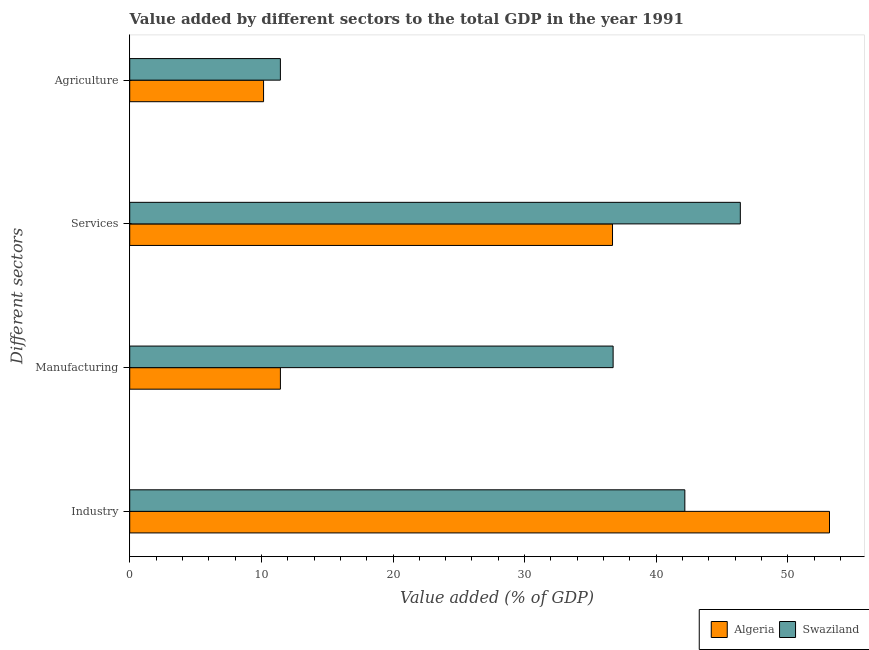How many different coloured bars are there?
Provide a short and direct response. 2. How many bars are there on the 2nd tick from the top?
Make the answer very short. 2. How many bars are there on the 4th tick from the bottom?
Ensure brevity in your answer.  2. What is the label of the 4th group of bars from the top?
Offer a very short reply. Industry. What is the value added by industrial sector in Algeria?
Offer a terse response. 53.16. Across all countries, what is the maximum value added by services sector?
Make the answer very short. 46.38. Across all countries, what is the minimum value added by manufacturing sector?
Keep it short and to the point. 11.45. In which country was the value added by services sector maximum?
Offer a terse response. Swaziland. In which country was the value added by industrial sector minimum?
Your answer should be compact. Swaziland. What is the total value added by services sector in the graph?
Offer a very short reply. 83.06. What is the difference between the value added by services sector in Swaziland and that in Algeria?
Give a very brief answer. 9.71. What is the difference between the value added by services sector in Algeria and the value added by agricultural sector in Swaziland?
Ensure brevity in your answer.  25.23. What is the average value added by agricultural sector per country?
Keep it short and to the point. 10.81. What is the difference between the value added by services sector and value added by industrial sector in Algeria?
Ensure brevity in your answer.  -16.48. What is the ratio of the value added by agricultural sector in Algeria to that in Swaziland?
Provide a short and direct response. 0.89. Is the value added by agricultural sector in Swaziland less than that in Algeria?
Your response must be concise. No. What is the difference between the highest and the second highest value added by industrial sector?
Provide a succinct answer. 10.99. What is the difference between the highest and the lowest value added by agricultural sector?
Make the answer very short. 1.28. What does the 1st bar from the top in Manufacturing represents?
Offer a very short reply. Swaziland. What does the 2nd bar from the bottom in Services represents?
Ensure brevity in your answer.  Swaziland. Is it the case that in every country, the sum of the value added by industrial sector and value added by manufacturing sector is greater than the value added by services sector?
Ensure brevity in your answer.  Yes. How many bars are there?
Give a very brief answer. 8. Are all the bars in the graph horizontal?
Offer a terse response. Yes. Are the values on the major ticks of X-axis written in scientific E-notation?
Provide a succinct answer. No. Does the graph contain grids?
Your answer should be compact. No. Where does the legend appear in the graph?
Offer a terse response. Bottom right. How many legend labels are there?
Offer a terse response. 2. How are the legend labels stacked?
Offer a very short reply. Horizontal. What is the title of the graph?
Your answer should be very brief. Value added by different sectors to the total GDP in the year 1991. Does "Vanuatu" appear as one of the legend labels in the graph?
Make the answer very short. No. What is the label or title of the X-axis?
Provide a short and direct response. Value added (% of GDP). What is the label or title of the Y-axis?
Your answer should be very brief. Different sectors. What is the Value added (% of GDP) in Algeria in Industry?
Provide a succinct answer. 53.16. What is the Value added (% of GDP) in Swaziland in Industry?
Keep it short and to the point. 42.17. What is the Value added (% of GDP) in Algeria in Manufacturing?
Your answer should be compact. 11.45. What is the Value added (% of GDP) in Swaziland in Manufacturing?
Make the answer very short. 36.72. What is the Value added (% of GDP) of Algeria in Services?
Your response must be concise. 36.67. What is the Value added (% of GDP) of Swaziland in Services?
Keep it short and to the point. 46.38. What is the Value added (% of GDP) in Algeria in Agriculture?
Give a very brief answer. 10.17. What is the Value added (% of GDP) of Swaziland in Agriculture?
Offer a very short reply. 11.45. Across all Different sectors, what is the maximum Value added (% of GDP) of Algeria?
Provide a succinct answer. 53.16. Across all Different sectors, what is the maximum Value added (% of GDP) in Swaziland?
Your answer should be very brief. 46.38. Across all Different sectors, what is the minimum Value added (% of GDP) in Algeria?
Keep it short and to the point. 10.17. Across all Different sectors, what is the minimum Value added (% of GDP) in Swaziland?
Keep it short and to the point. 11.45. What is the total Value added (% of GDP) in Algeria in the graph?
Your answer should be compact. 111.45. What is the total Value added (% of GDP) in Swaziland in the graph?
Offer a terse response. 136.72. What is the difference between the Value added (% of GDP) of Algeria in Industry and that in Manufacturing?
Ensure brevity in your answer.  41.71. What is the difference between the Value added (% of GDP) in Swaziland in Industry and that in Manufacturing?
Your answer should be compact. 5.45. What is the difference between the Value added (% of GDP) in Algeria in Industry and that in Services?
Offer a very short reply. 16.48. What is the difference between the Value added (% of GDP) of Swaziland in Industry and that in Services?
Provide a succinct answer. -4.21. What is the difference between the Value added (% of GDP) of Algeria in Industry and that in Agriculture?
Provide a short and direct response. 42.99. What is the difference between the Value added (% of GDP) of Swaziland in Industry and that in Agriculture?
Keep it short and to the point. 30.72. What is the difference between the Value added (% of GDP) in Algeria in Manufacturing and that in Services?
Provide a short and direct response. -25.23. What is the difference between the Value added (% of GDP) of Swaziland in Manufacturing and that in Services?
Provide a short and direct response. -9.66. What is the difference between the Value added (% of GDP) in Algeria in Manufacturing and that in Agriculture?
Keep it short and to the point. 1.28. What is the difference between the Value added (% of GDP) in Swaziland in Manufacturing and that in Agriculture?
Ensure brevity in your answer.  25.28. What is the difference between the Value added (% of GDP) of Algeria in Services and that in Agriculture?
Keep it short and to the point. 26.51. What is the difference between the Value added (% of GDP) of Swaziland in Services and that in Agriculture?
Your answer should be very brief. 34.94. What is the difference between the Value added (% of GDP) in Algeria in Industry and the Value added (% of GDP) in Swaziland in Manufacturing?
Give a very brief answer. 16.44. What is the difference between the Value added (% of GDP) in Algeria in Industry and the Value added (% of GDP) in Swaziland in Services?
Your answer should be very brief. 6.77. What is the difference between the Value added (% of GDP) of Algeria in Industry and the Value added (% of GDP) of Swaziland in Agriculture?
Offer a terse response. 41.71. What is the difference between the Value added (% of GDP) in Algeria in Manufacturing and the Value added (% of GDP) in Swaziland in Services?
Give a very brief answer. -34.94. What is the difference between the Value added (% of GDP) of Algeria in Services and the Value added (% of GDP) of Swaziland in Agriculture?
Ensure brevity in your answer.  25.23. What is the average Value added (% of GDP) in Algeria per Different sectors?
Provide a short and direct response. 27.86. What is the average Value added (% of GDP) in Swaziland per Different sectors?
Give a very brief answer. 34.18. What is the difference between the Value added (% of GDP) in Algeria and Value added (% of GDP) in Swaziland in Industry?
Provide a short and direct response. 10.99. What is the difference between the Value added (% of GDP) in Algeria and Value added (% of GDP) in Swaziland in Manufacturing?
Your answer should be compact. -25.27. What is the difference between the Value added (% of GDP) of Algeria and Value added (% of GDP) of Swaziland in Services?
Provide a short and direct response. -9.71. What is the difference between the Value added (% of GDP) of Algeria and Value added (% of GDP) of Swaziland in Agriculture?
Offer a very short reply. -1.28. What is the ratio of the Value added (% of GDP) in Algeria in Industry to that in Manufacturing?
Your response must be concise. 4.64. What is the ratio of the Value added (% of GDP) in Swaziland in Industry to that in Manufacturing?
Provide a succinct answer. 1.15. What is the ratio of the Value added (% of GDP) in Algeria in Industry to that in Services?
Give a very brief answer. 1.45. What is the ratio of the Value added (% of GDP) of Algeria in Industry to that in Agriculture?
Give a very brief answer. 5.23. What is the ratio of the Value added (% of GDP) of Swaziland in Industry to that in Agriculture?
Your answer should be very brief. 3.68. What is the ratio of the Value added (% of GDP) in Algeria in Manufacturing to that in Services?
Keep it short and to the point. 0.31. What is the ratio of the Value added (% of GDP) of Swaziland in Manufacturing to that in Services?
Offer a terse response. 0.79. What is the ratio of the Value added (% of GDP) of Algeria in Manufacturing to that in Agriculture?
Ensure brevity in your answer.  1.13. What is the ratio of the Value added (% of GDP) in Swaziland in Manufacturing to that in Agriculture?
Your answer should be compact. 3.21. What is the ratio of the Value added (% of GDP) of Algeria in Services to that in Agriculture?
Your answer should be compact. 3.61. What is the ratio of the Value added (% of GDP) in Swaziland in Services to that in Agriculture?
Your response must be concise. 4.05. What is the difference between the highest and the second highest Value added (% of GDP) of Algeria?
Give a very brief answer. 16.48. What is the difference between the highest and the second highest Value added (% of GDP) in Swaziland?
Make the answer very short. 4.21. What is the difference between the highest and the lowest Value added (% of GDP) of Algeria?
Ensure brevity in your answer.  42.99. What is the difference between the highest and the lowest Value added (% of GDP) in Swaziland?
Make the answer very short. 34.94. 